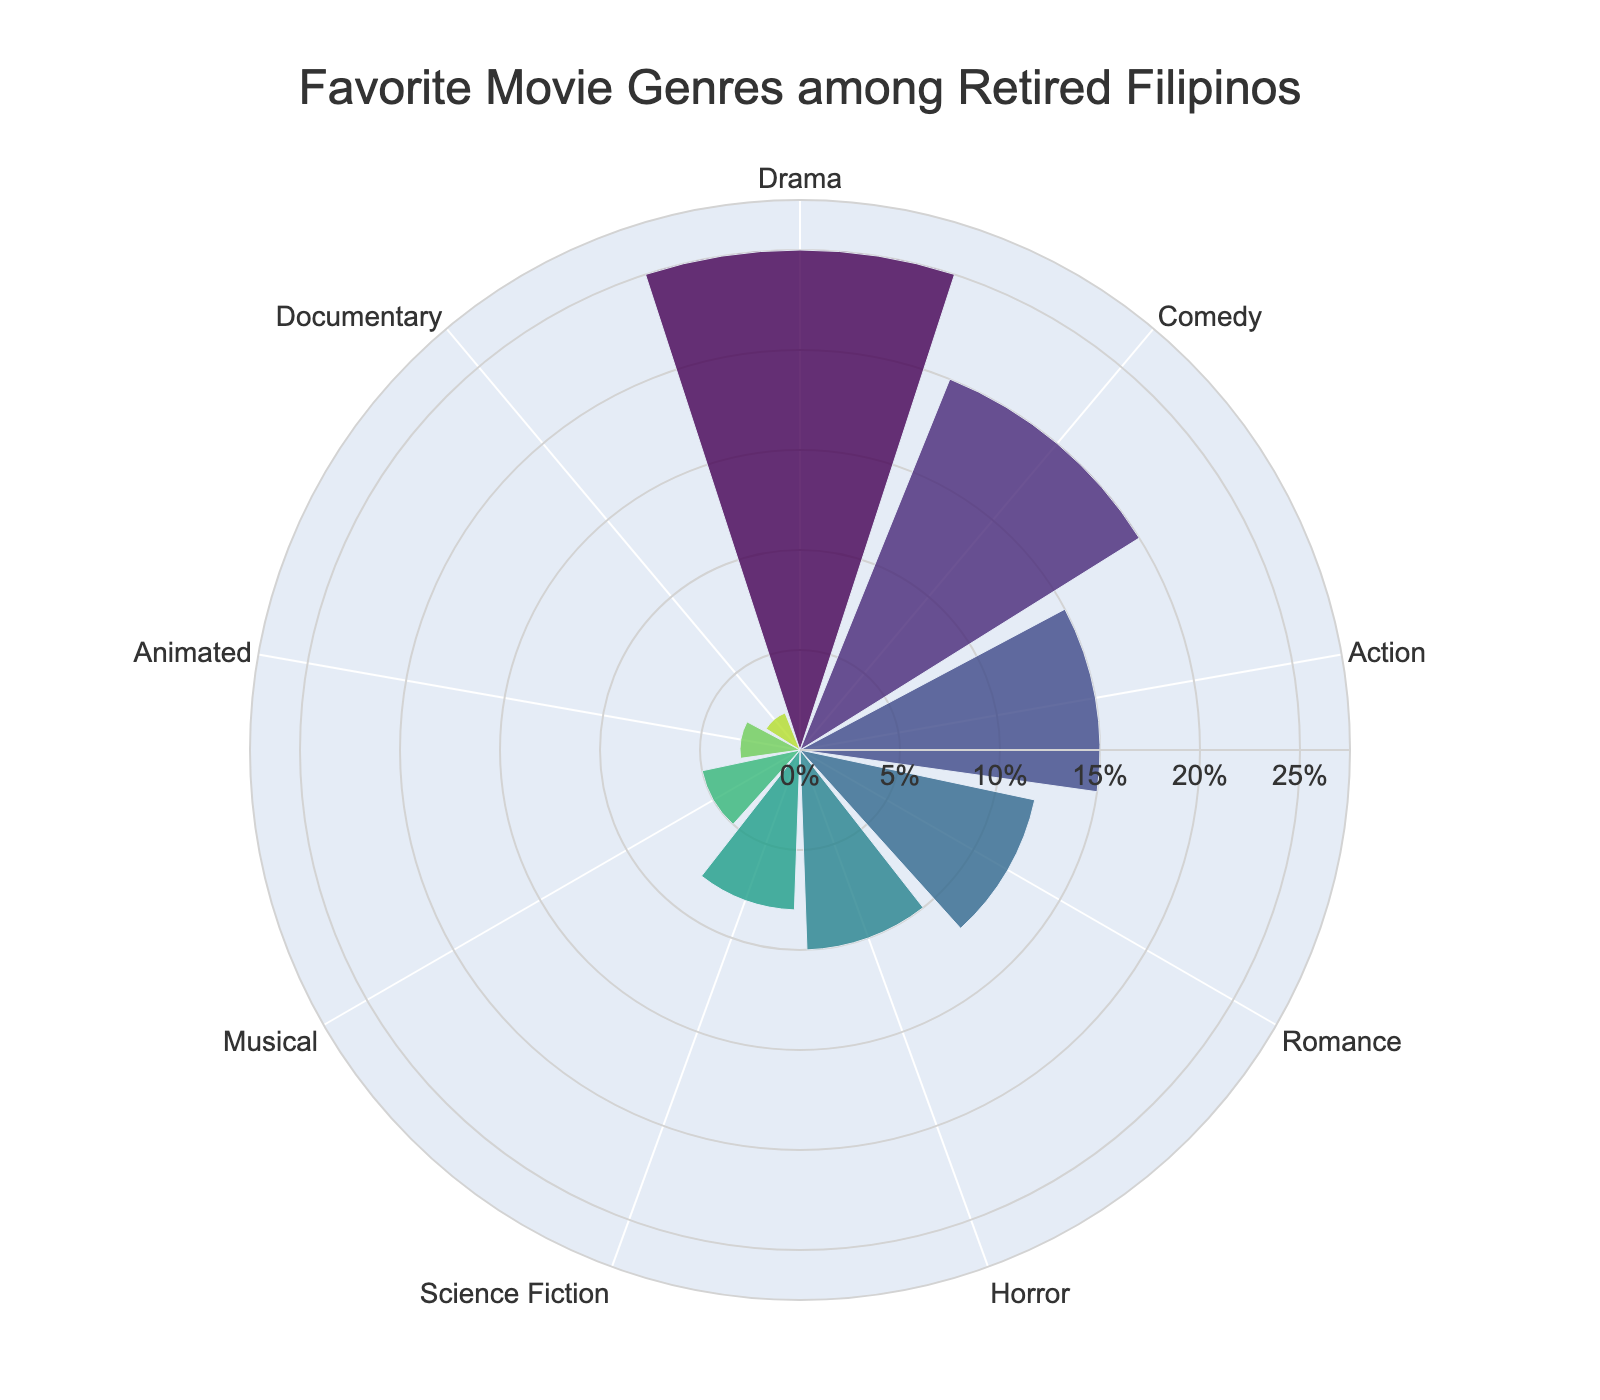What genre has the highest percentage of favorites among retired Filipinos? The genre with the highest percentage can be directly observed from the chart by identifying the largest sector.
Answer: Drama How much higher is the percentage of Comedy compared to Animated? To find this, subtract the percentage of Animated from Comedy: 20% - 3%.
Answer: 17% What is the total percentage for the top 3 favorite genres? Sum the percentages of Drama, Comedy, and Action: 25% + 20% + 15%.
Answer: 60% Which genre has the smallest percentage? The smallest sector on the chart corresponds to the genre with the smallest percentage.
Answer: Documentary How do the percentages of Horror and Science Fiction compare? Find both percentages (Horror = 10%, Science Fiction = 8%) and compare them.
Answer: Horror is 2% higher than Science Fiction What's the percentage difference between Action and Romance genres? Subtract Romance's percentage from Action's: 15% - 12%.
Answer: 3% Name all the genres whose percentage is 5% or less. Identify all genres with percentages of 5% or less from the chart.
Answer: Musical (5%), Animated (3%), Documentary (2%) If the percentages for Romance and Horror are combined, what is the new percentage? Sum the percentages for Romance and Horror: 12% + 10%.
Answer: 22% Which genre ranks third in terms of favorite percentage among retired Filipinos? Identify the third largest sector on the chart.
Answer: Action What is the average percentage of all the genres listed? Sum all percentages and divide by the number of genres: (25% + 20% + 15% + 12% + 10% + 8% + 5% + 3% + 2%) / 9.
Answer: 11.1% 